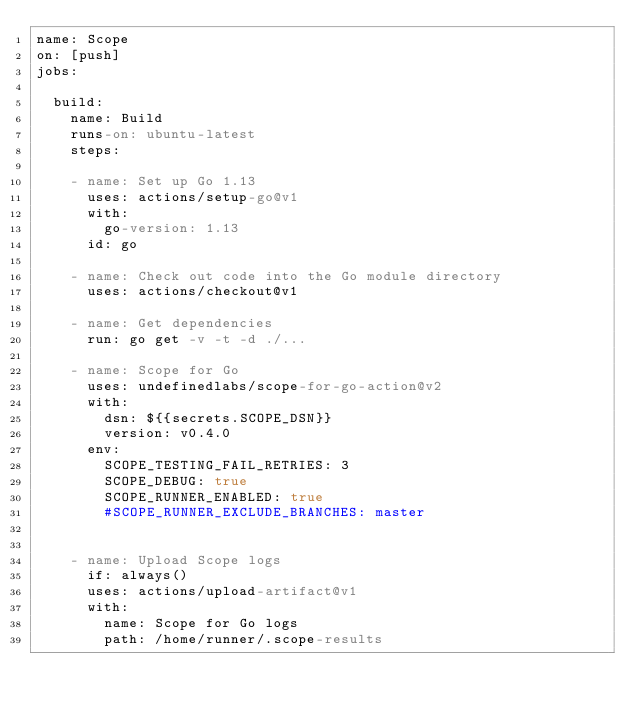Convert code to text. <code><loc_0><loc_0><loc_500><loc_500><_YAML_>name: Scope
on: [push]
jobs:

  build:
    name: Build
    runs-on: ubuntu-latest
    steps:

    - name: Set up Go 1.13
      uses: actions/setup-go@v1
      with:
        go-version: 1.13
      id: go

    - name: Check out code into the Go module directory
      uses: actions/checkout@v1

    - name: Get dependencies
      run: go get -v -t -d ./...

    - name: Scope for Go
      uses: undefinedlabs/scope-for-go-action@v2
      with:
        dsn: ${{secrets.SCOPE_DSN}}
        version: v0.4.0
      env:
        SCOPE_TESTING_FAIL_RETRIES: 3
        SCOPE_DEBUG: true
        SCOPE_RUNNER_ENABLED: true
        #SCOPE_RUNNER_EXCLUDE_BRANCHES: master


    - name: Upload Scope logs
      if: always()
      uses: actions/upload-artifact@v1
      with:
        name: Scope for Go logs
        path: /home/runner/.scope-results
</code> 